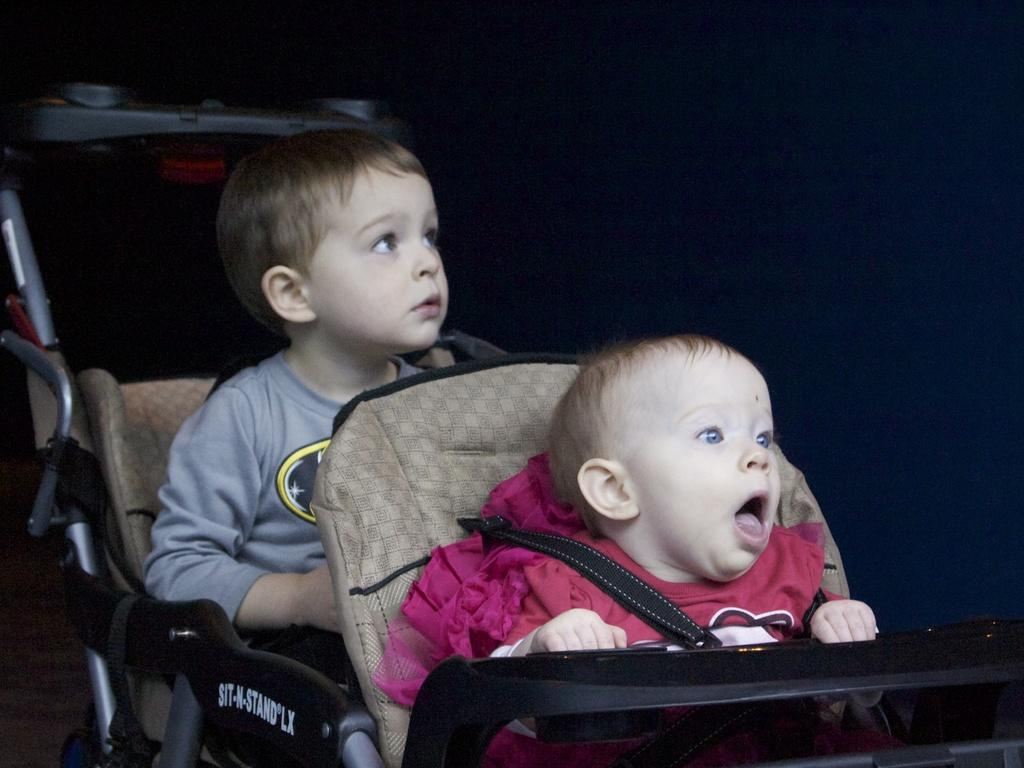Who or what can be seen sitting on the vehicle in the image? There are two people sitting on a vehicle in the image. What can be seen in the background of the image? There is a wall visible in the background. What is written or displayed on the vehicle? There is text on the vehicle. What is the surface that the vehicle is on or near? There is a floor visible at the bottom of the image. What type of government building is visible in the image? There is no government building visible in the image. 